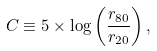<formula> <loc_0><loc_0><loc_500><loc_500>C \equiv 5 \times \log \left ( \frac { r _ { 8 0 } } { r _ { 2 0 } } \right ) ,</formula> 